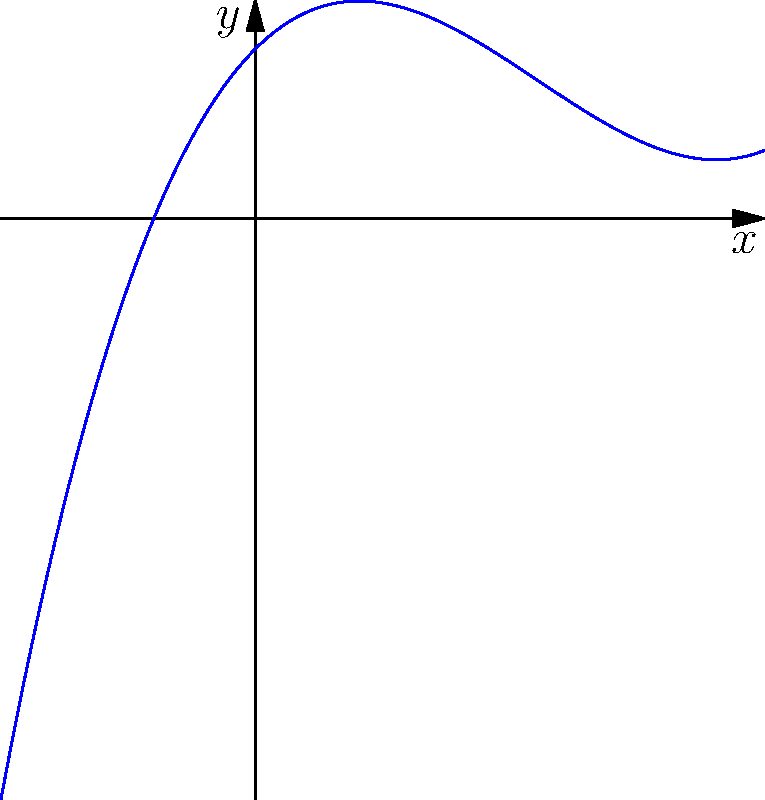Based on the graph of the polynomial function shown above, what is the behavior of the function as $x$ approaches positive infinity? Describe the end behavior in mathematical notation. To determine the end behavior of a polynomial function as $x$ approaches positive infinity, we need to analyze the graph's rightmost portion. Let's follow these steps:

1. Observe the graph's overall shape: The curve starts low on the left, dips in the middle, and then rises steeply on the right.

2. Focus on the rightmost part: As we move further to the right (i.e., as $x$ increases), the curve continues to rise without bound.

3. Identify the curve's nature: The graph appears to be increasing at an increasing rate, suggesting a higher-degree term dominates as $x$ grows large.

4. Determine the leading term: Given the shape, this is likely a cubic function with a positive leading coefficient.

5. Conclude the end behavior: As $x$ approaches positive infinity, $y$ also approaches positive infinity.

6. Express in mathematical notation: We write this as $\lim_{x \to \infty} f(x) = \infty$.

This notation means that as $x$ grows arbitrarily large, $f(x)$ also grows without bound in the positive direction.
Answer: $\lim_{x \to \infty} f(x) = \infty$ 